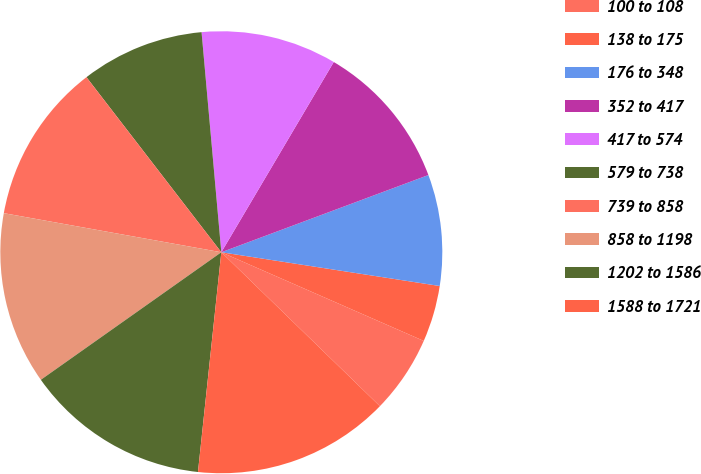Convert chart. <chart><loc_0><loc_0><loc_500><loc_500><pie_chart><fcel>100 to 108<fcel>138 to 175<fcel>176 to 348<fcel>352 to 417<fcel>417 to 574<fcel>579 to 738<fcel>739 to 858<fcel>858 to 1198<fcel>1202 to 1586<fcel>1588 to 1721<nl><fcel>5.69%<fcel>4.13%<fcel>8.12%<fcel>10.82%<fcel>9.92%<fcel>9.02%<fcel>11.72%<fcel>12.62%<fcel>13.52%<fcel>14.42%<nl></chart> 